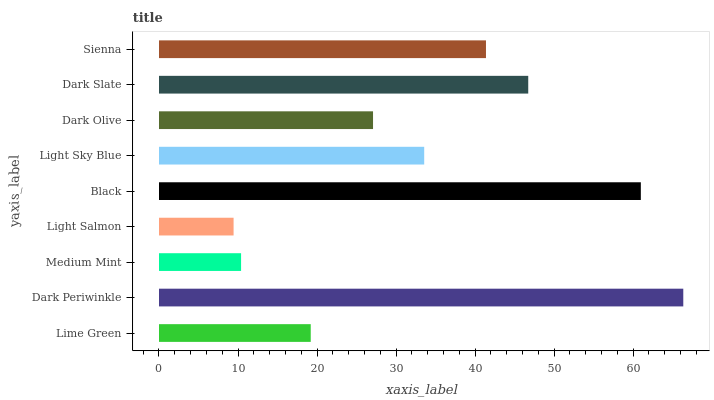Is Light Salmon the minimum?
Answer yes or no. Yes. Is Dark Periwinkle the maximum?
Answer yes or no. Yes. Is Medium Mint the minimum?
Answer yes or no. No. Is Medium Mint the maximum?
Answer yes or no. No. Is Dark Periwinkle greater than Medium Mint?
Answer yes or no. Yes. Is Medium Mint less than Dark Periwinkle?
Answer yes or no. Yes. Is Medium Mint greater than Dark Periwinkle?
Answer yes or no. No. Is Dark Periwinkle less than Medium Mint?
Answer yes or no. No. Is Light Sky Blue the high median?
Answer yes or no. Yes. Is Light Sky Blue the low median?
Answer yes or no. Yes. Is Medium Mint the high median?
Answer yes or no. No. Is Light Salmon the low median?
Answer yes or no. No. 